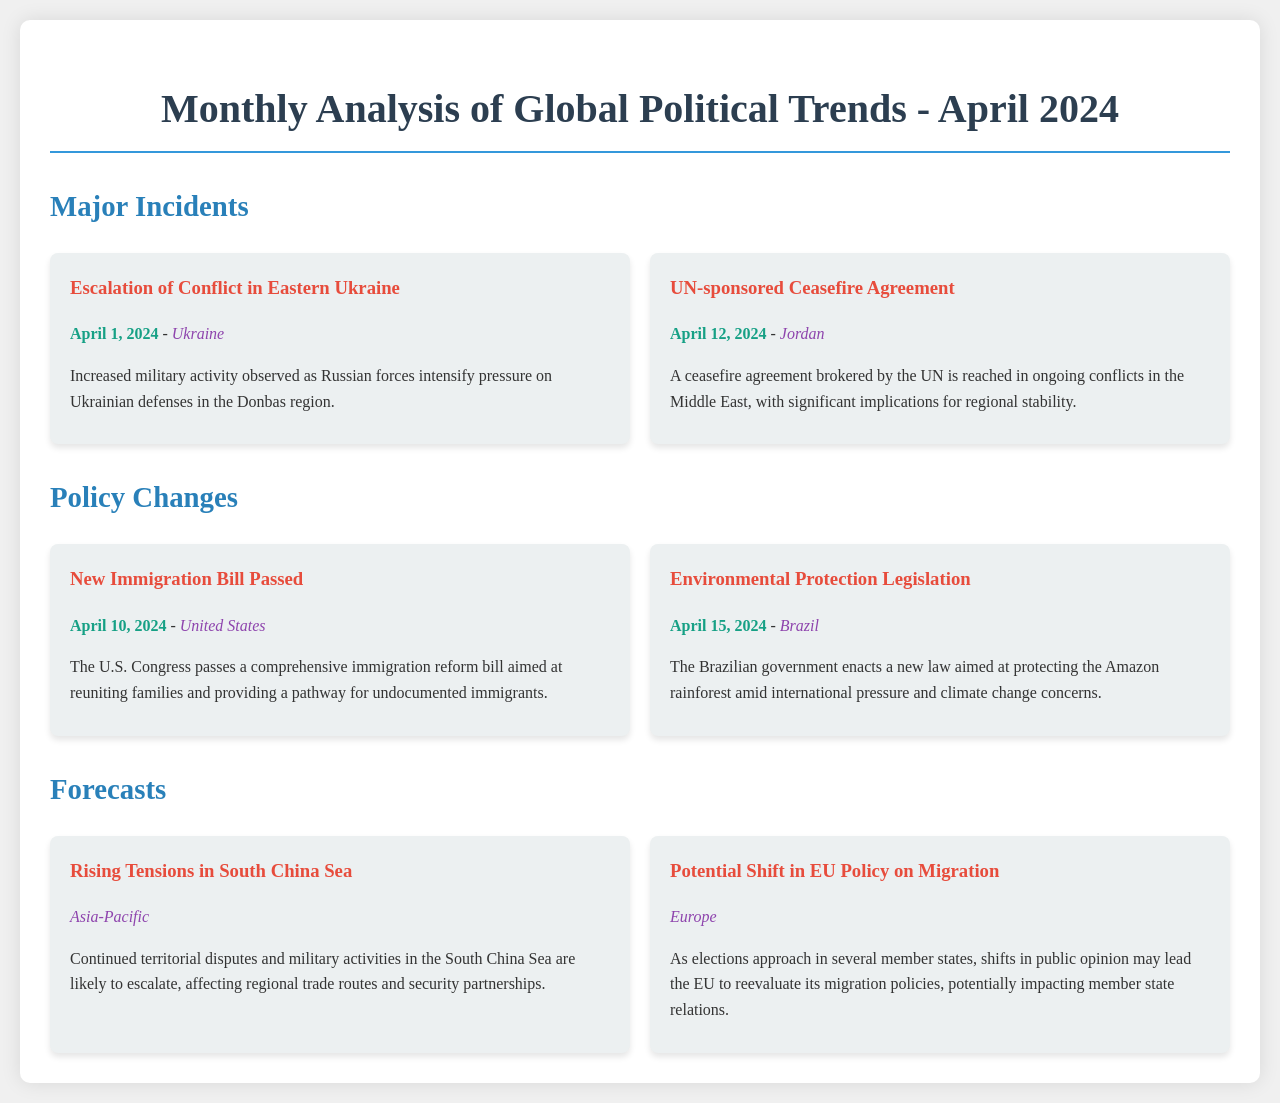What is the most recent major incident listed? The document lists the most recent major incident as "Escalation of Conflict in Eastern Ukraine" which occurred on April 1, 2024.
Answer: Escalation of Conflict in Eastern Ukraine What policy change was enacted in Brazil? The document mentions a "New Immigration Bill Passed" for the U.S. and "Environmental Protection Legislation" in Brazil, which aims at protecting the Amazon rainforest.
Answer: Environmental Protection Legislation When was the UN-sponsored Ceasefire Agreement reached? This information is found in the section about major incidents, stating the ceasefire agreement was reached on April 12, 2024.
Answer: April 12, 2024 What is the forecast regarding the South China Sea? The forecast discusses "Rising Tensions in South China Sea," indicating likely escalation in territorial disputes and military activities.
Answer: Rising Tensions in South China Sea Which country passed an immigration reform bill in April 2024? The document specifically mentions that the U.S. Congress passed the immigration reform bill in April 2024.
Answer: United States What is the location of the potential shift in EU policy on migration? This forecast indicates that the potential shift in EU policy regarding migration will occur in Europe, particularly with upcoming elections.
Answer: Europe Which incident occurred first in April 2024? By looking at the dates, the "Escalation of Conflict in Eastern Ukraine" on April 1, 2024, occurred before the others listed in the document.
Answer: April 1, 2024 What is the theme of the forecasts section? The forecast section explores the potential shifts and issues affecting global politics, specifically concerning tensions and migration policies.
Answer: Tensions and migration policies 